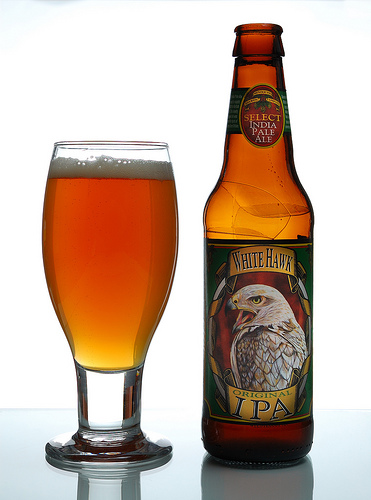<image>
Is there a foam on the beer? Yes. Looking at the image, I can see the foam is positioned on top of the beer, with the beer providing support. Is the beer to the right of the glass? Yes. From this viewpoint, the beer is positioned to the right side relative to the glass. Is the beer in the glass? No. The beer is not contained within the glass. These objects have a different spatial relationship. Where is the glass in relation to the bottle? Is it in front of the bottle? No. The glass is not in front of the bottle. The spatial positioning shows a different relationship between these objects. 